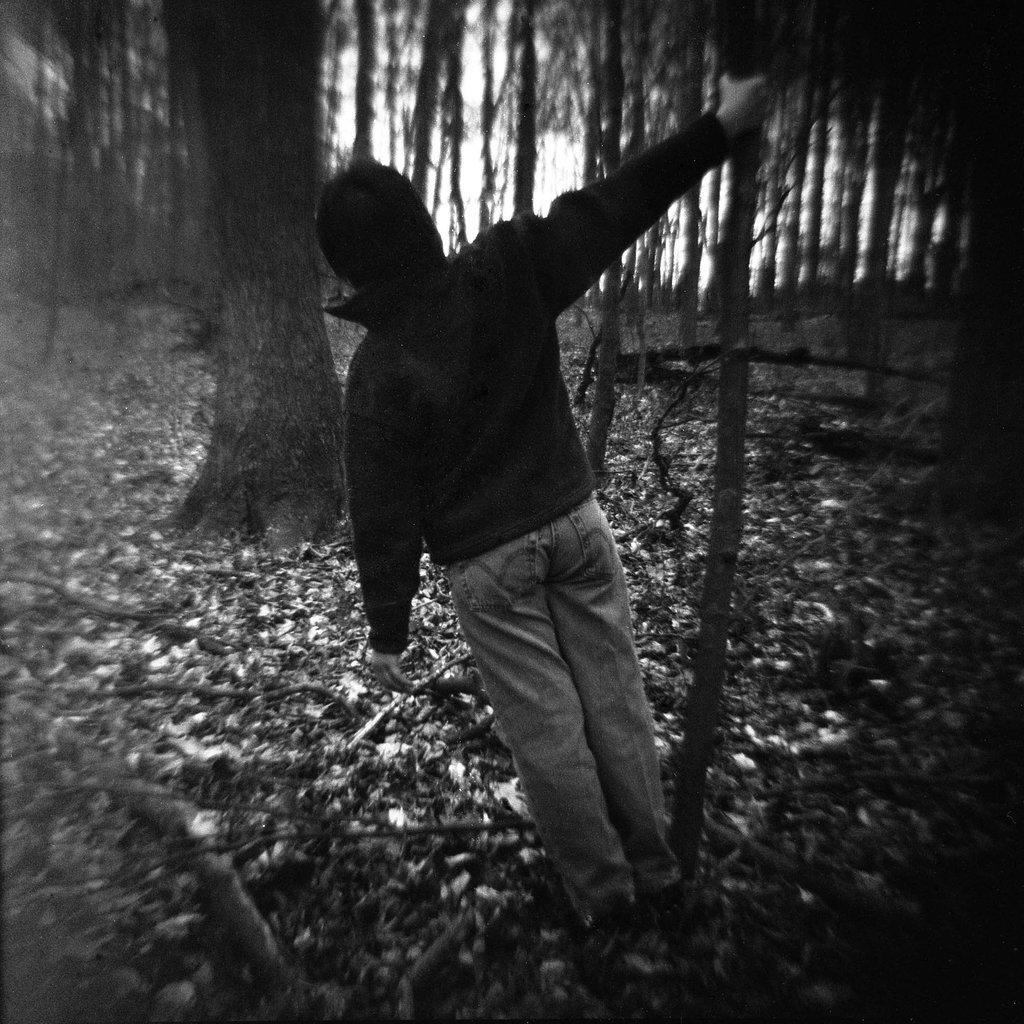Can you describe this image briefly? In this picture I can see a human holding a tree bark with his hand and i can see few trees and leaves on the ground. 